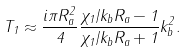Convert formula to latex. <formula><loc_0><loc_0><loc_500><loc_500>T _ { 1 } \approx \frac { i \pi R _ { a } ^ { 2 } } { 4 } \frac { \chi _ { 1 } / k _ { b } R _ { a } - 1 } { \chi _ { 1 } / k _ { b } R _ { a } + 1 } k _ { b } ^ { 2 } .</formula> 